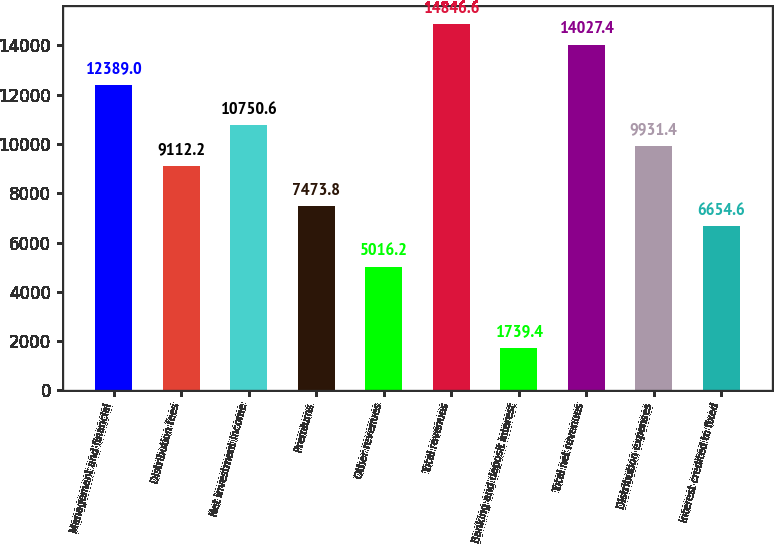<chart> <loc_0><loc_0><loc_500><loc_500><bar_chart><fcel>Management and financial<fcel>Distribution fees<fcel>Net investment income<fcel>Premiums<fcel>Other revenues<fcel>Total revenues<fcel>Banking and deposit interest<fcel>Total net revenues<fcel>Distribution expenses<fcel>Interest credited to fixed<nl><fcel>12389<fcel>9112.2<fcel>10750.6<fcel>7473.8<fcel>5016.2<fcel>14846.6<fcel>1739.4<fcel>14027.4<fcel>9931.4<fcel>6654.6<nl></chart> 